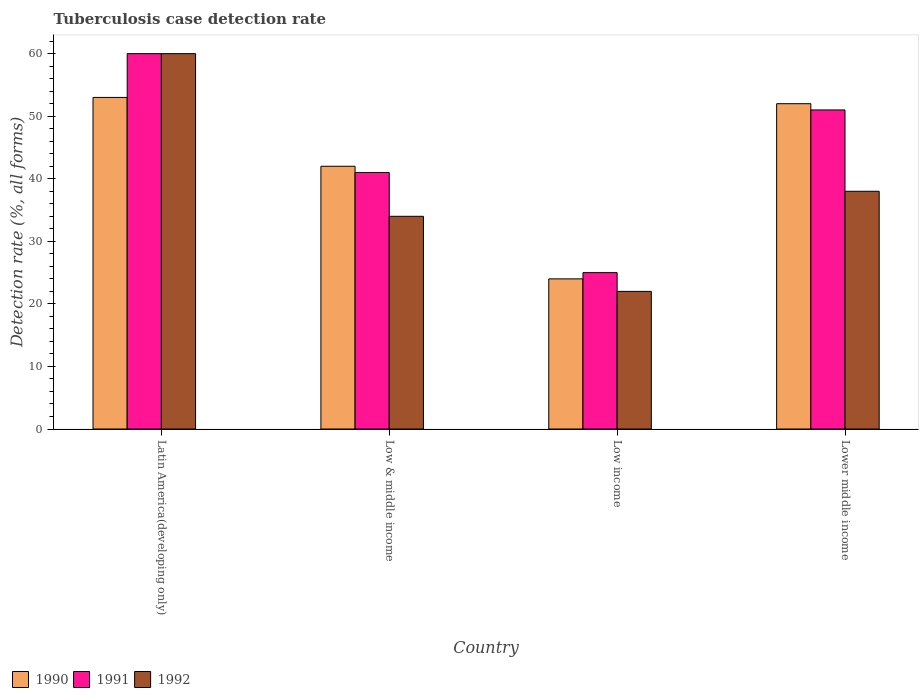Are the number of bars per tick equal to the number of legend labels?
Provide a succinct answer. Yes. How many bars are there on the 3rd tick from the left?
Ensure brevity in your answer.  3. In how many cases, is the number of bars for a given country not equal to the number of legend labels?
Ensure brevity in your answer.  0. In which country was the tuberculosis case detection rate in in 1991 maximum?
Give a very brief answer. Latin America(developing only). In which country was the tuberculosis case detection rate in in 1992 minimum?
Your answer should be very brief. Low income. What is the total tuberculosis case detection rate in in 1992 in the graph?
Your answer should be very brief. 154. What is the difference between the tuberculosis case detection rate in in 1992 in Latin America(developing only) and the tuberculosis case detection rate in in 1990 in Lower middle income?
Ensure brevity in your answer.  8. What is the average tuberculosis case detection rate in in 1990 per country?
Offer a very short reply. 42.75. In how many countries, is the tuberculosis case detection rate in in 1992 greater than 32 %?
Ensure brevity in your answer.  3. What is the ratio of the tuberculosis case detection rate in in 1992 in Latin America(developing only) to that in Low income?
Make the answer very short. 2.73. Is the tuberculosis case detection rate in in 1991 in Low income less than that in Lower middle income?
Make the answer very short. Yes. Is the difference between the tuberculosis case detection rate in in 1990 in Latin America(developing only) and Lower middle income greater than the difference between the tuberculosis case detection rate in in 1992 in Latin America(developing only) and Lower middle income?
Offer a very short reply. No. What does the 3rd bar from the right in Low & middle income represents?
Keep it short and to the point. 1990. Is it the case that in every country, the sum of the tuberculosis case detection rate in in 1990 and tuberculosis case detection rate in in 1991 is greater than the tuberculosis case detection rate in in 1992?
Provide a short and direct response. Yes. Are all the bars in the graph horizontal?
Provide a succinct answer. No. Are the values on the major ticks of Y-axis written in scientific E-notation?
Keep it short and to the point. No. How many legend labels are there?
Your answer should be compact. 3. How are the legend labels stacked?
Give a very brief answer. Horizontal. What is the title of the graph?
Your answer should be compact. Tuberculosis case detection rate. What is the label or title of the X-axis?
Provide a short and direct response. Country. What is the label or title of the Y-axis?
Give a very brief answer. Detection rate (%, all forms). What is the Detection rate (%, all forms) of 1991 in Latin America(developing only)?
Give a very brief answer. 60. What is the Detection rate (%, all forms) in 1992 in Latin America(developing only)?
Ensure brevity in your answer.  60. What is the Detection rate (%, all forms) of 1990 in Low & middle income?
Provide a short and direct response. 42. What is the Detection rate (%, all forms) in 1990 in Low income?
Offer a very short reply. 24. What is the Detection rate (%, all forms) of 1991 in Low income?
Keep it short and to the point. 25. What is the Detection rate (%, all forms) in 1992 in Low income?
Your answer should be very brief. 22. What is the Detection rate (%, all forms) of 1990 in Lower middle income?
Your response must be concise. 52. What is the Detection rate (%, all forms) of 1991 in Lower middle income?
Provide a succinct answer. 51. What is the Detection rate (%, all forms) of 1992 in Lower middle income?
Make the answer very short. 38. Across all countries, what is the maximum Detection rate (%, all forms) of 1990?
Make the answer very short. 53. Across all countries, what is the minimum Detection rate (%, all forms) in 1990?
Keep it short and to the point. 24. What is the total Detection rate (%, all forms) in 1990 in the graph?
Give a very brief answer. 171. What is the total Detection rate (%, all forms) of 1991 in the graph?
Make the answer very short. 177. What is the total Detection rate (%, all forms) in 1992 in the graph?
Your response must be concise. 154. What is the difference between the Detection rate (%, all forms) of 1991 in Latin America(developing only) and that in Low & middle income?
Your response must be concise. 19. What is the difference between the Detection rate (%, all forms) in 1992 in Latin America(developing only) and that in Low & middle income?
Provide a succinct answer. 26. What is the difference between the Detection rate (%, all forms) of 1990 in Latin America(developing only) and that in Low income?
Your answer should be very brief. 29. What is the difference between the Detection rate (%, all forms) of 1992 in Latin America(developing only) and that in Low income?
Provide a succinct answer. 38. What is the difference between the Detection rate (%, all forms) in 1990 in Latin America(developing only) and that in Lower middle income?
Give a very brief answer. 1. What is the difference between the Detection rate (%, all forms) of 1990 in Latin America(developing only) and the Detection rate (%, all forms) of 1991 in Low & middle income?
Your answer should be compact. 12. What is the difference between the Detection rate (%, all forms) in 1991 in Latin America(developing only) and the Detection rate (%, all forms) in 1992 in Low income?
Make the answer very short. 38. What is the difference between the Detection rate (%, all forms) of 1990 in Low & middle income and the Detection rate (%, all forms) of 1991 in Low income?
Offer a terse response. 17. What is the difference between the Detection rate (%, all forms) of 1990 in Low & middle income and the Detection rate (%, all forms) of 1992 in Lower middle income?
Ensure brevity in your answer.  4. What is the difference between the Detection rate (%, all forms) in 1991 in Low & middle income and the Detection rate (%, all forms) in 1992 in Lower middle income?
Your answer should be compact. 3. What is the difference between the Detection rate (%, all forms) in 1990 in Low income and the Detection rate (%, all forms) in 1991 in Lower middle income?
Provide a succinct answer. -27. What is the difference between the Detection rate (%, all forms) in 1991 in Low income and the Detection rate (%, all forms) in 1992 in Lower middle income?
Your response must be concise. -13. What is the average Detection rate (%, all forms) of 1990 per country?
Provide a succinct answer. 42.75. What is the average Detection rate (%, all forms) of 1991 per country?
Give a very brief answer. 44.25. What is the average Detection rate (%, all forms) in 1992 per country?
Keep it short and to the point. 38.5. What is the difference between the Detection rate (%, all forms) in 1990 and Detection rate (%, all forms) in 1992 in Latin America(developing only)?
Provide a succinct answer. -7. What is the difference between the Detection rate (%, all forms) in 1991 and Detection rate (%, all forms) in 1992 in Latin America(developing only)?
Provide a succinct answer. 0. What is the difference between the Detection rate (%, all forms) of 1990 and Detection rate (%, all forms) of 1991 in Low & middle income?
Your answer should be compact. 1. What is the difference between the Detection rate (%, all forms) in 1990 and Detection rate (%, all forms) in 1992 in Low & middle income?
Ensure brevity in your answer.  8. What is the difference between the Detection rate (%, all forms) in 1990 and Detection rate (%, all forms) in 1991 in Low income?
Ensure brevity in your answer.  -1. What is the difference between the Detection rate (%, all forms) of 1990 and Detection rate (%, all forms) of 1992 in Low income?
Your response must be concise. 2. What is the difference between the Detection rate (%, all forms) of 1990 and Detection rate (%, all forms) of 1991 in Lower middle income?
Offer a very short reply. 1. What is the difference between the Detection rate (%, all forms) of 1990 and Detection rate (%, all forms) of 1992 in Lower middle income?
Your answer should be compact. 14. What is the ratio of the Detection rate (%, all forms) in 1990 in Latin America(developing only) to that in Low & middle income?
Provide a succinct answer. 1.26. What is the ratio of the Detection rate (%, all forms) of 1991 in Latin America(developing only) to that in Low & middle income?
Provide a short and direct response. 1.46. What is the ratio of the Detection rate (%, all forms) of 1992 in Latin America(developing only) to that in Low & middle income?
Ensure brevity in your answer.  1.76. What is the ratio of the Detection rate (%, all forms) in 1990 in Latin America(developing only) to that in Low income?
Provide a succinct answer. 2.21. What is the ratio of the Detection rate (%, all forms) in 1992 in Latin America(developing only) to that in Low income?
Your answer should be compact. 2.73. What is the ratio of the Detection rate (%, all forms) in 1990 in Latin America(developing only) to that in Lower middle income?
Make the answer very short. 1.02. What is the ratio of the Detection rate (%, all forms) in 1991 in Latin America(developing only) to that in Lower middle income?
Your answer should be compact. 1.18. What is the ratio of the Detection rate (%, all forms) in 1992 in Latin America(developing only) to that in Lower middle income?
Give a very brief answer. 1.58. What is the ratio of the Detection rate (%, all forms) in 1990 in Low & middle income to that in Low income?
Give a very brief answer. 1.75. What is the ratio of the Detection rate (%, all forms) in 1991 in Low & middle income to that in Low income?
Your answer should be compact. 1.64. What is the ratio of the Detection rate (%, all forms) in 1992 in Low & middle income to that in Low income?
Make the answer very short. 1.55. What is the ratio of the Detection rate (%, all forms) of 1990 in Low & middle income to that in Lower middle income?
Your answer should be compact. 0.81. What is the ratio of the Detection rate (%, all forms) of 1991 in Low & middle income to that in Lower middle income?
Keep it short and to the point. 0.8. What is the ratio of the Detection rate (%, all forms) in 1992 in Low & middle income to that in Lower middle income?
Make the answer very short. 0.89. What is the ratio of the Detection rate (%, all forms) of 1990 in Low income to that in Lower middle income?
Give a very brief answer. 0.46. What is the ratio of the Detection rate (%, all forms) of 1991 in Low income to that in Lower middle income?
Your response must be concise. 0.49. What is the ratio of the Detection rate (%, all forms) in 1992 in Low income to that in Lower middle income?
Keep it short and to the point. 0.58. What is the difference between the highest and the second highest Detection rate (%, all forms) in 1990?
Give a very brief answer. 1. What is the difference between the highest and the second highest Detection rate (%, all forms) of 1992?
Provide a short and direct response. 22. What is the difference between the highest and the lowest Detection rate (%, all forms) in 1990?
Keep it short and to the point. 29. 